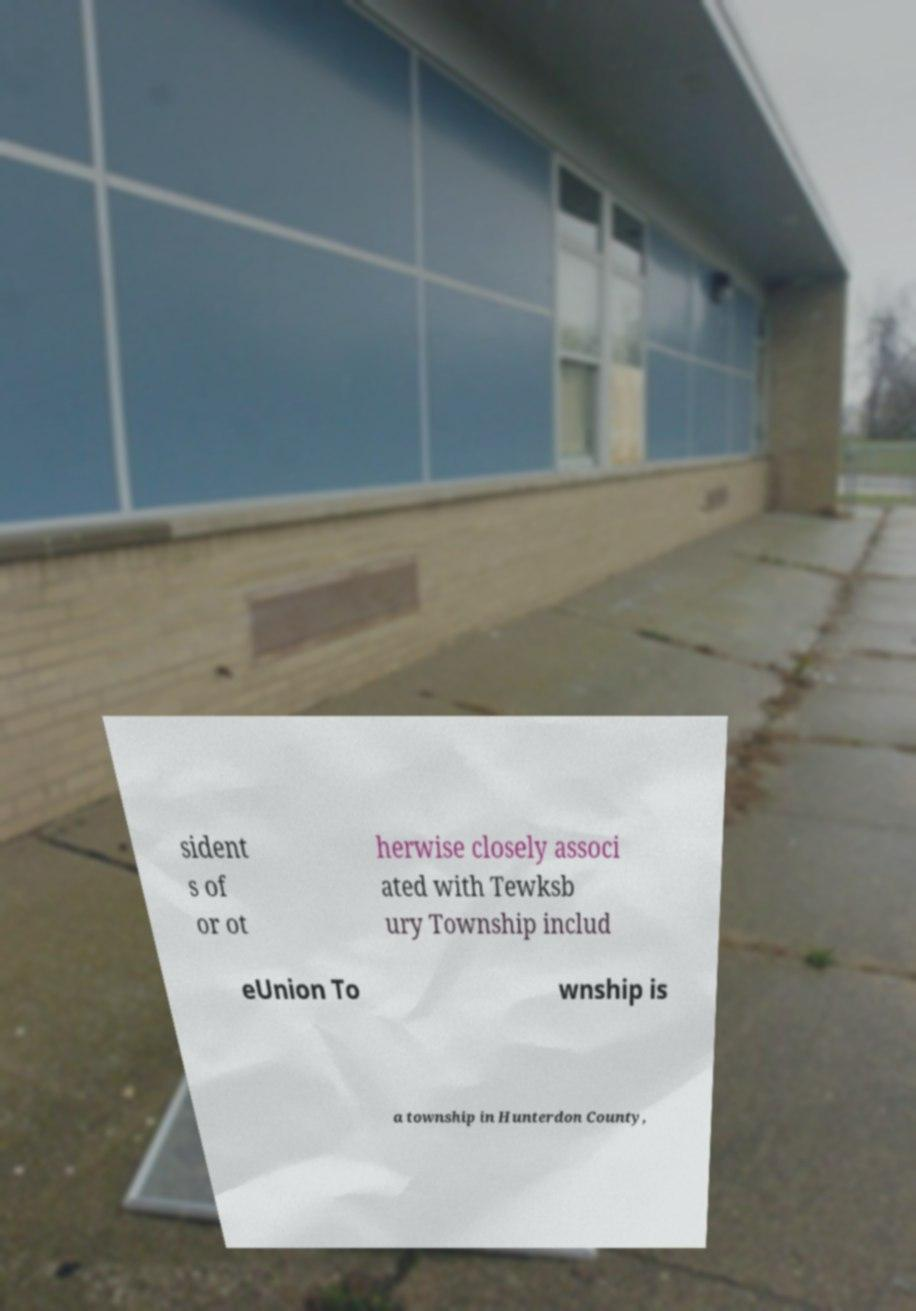Please identify and transcribe the text found in this image. sident s of or ot herwise closely associ ated with Tewksb ury Township includ eUnion To wnship is a township in Hunterdon County, 